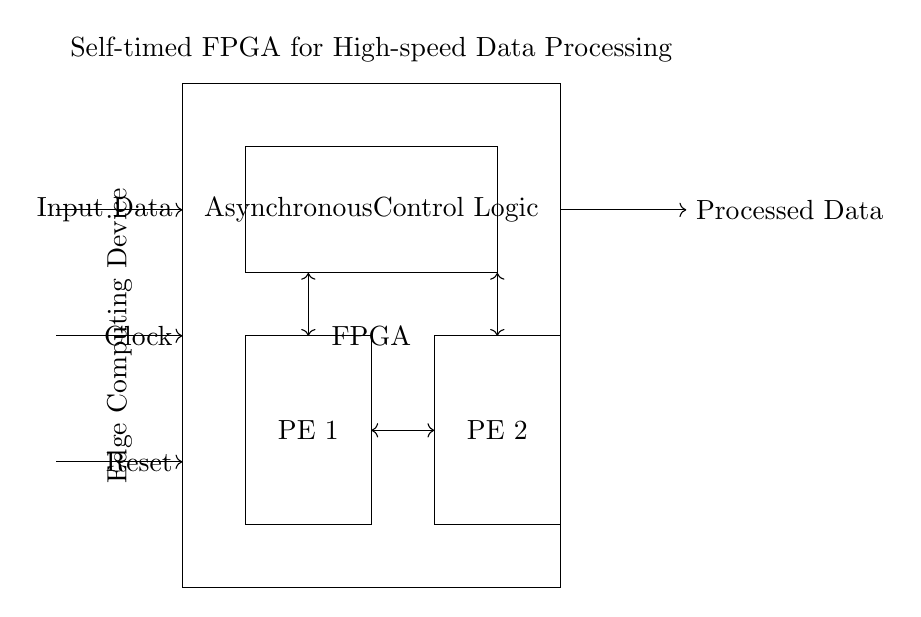What is the main component of the circuit? The main component, as represented by the rectangle on the left side, is the FPGA. It is the central processing unit that handles data processing tasks.
Answer: FPGA What are the processing elements in the circuit? The processing elements are labeled as PE 1 and PE 2, represented by the two rectangles in the lower part of the diagram, indicating their functions in data processing.
Answer: PE 1 and PE 2 How many handshake signals are present in the circuit? There are two handshake signals in the circuit, indicated by the double-headed arrows between the asynchronous control logic and the processing elements.
Answer: 2 What kind of logic is implemented in the circuit? The circuit implements asynchronous control logic, which is specified in the rectangle labeled with "Asynchronous Control Logic" located at the center of the diagram.
Answer: Asynchronous Control Logic What type of computing application is indicated in the diagram? The circuit is designed for edge computing applications, as noted by the label "Edge Computing Device" located on the left side of the FPGA.
Answer: Edge Computing 